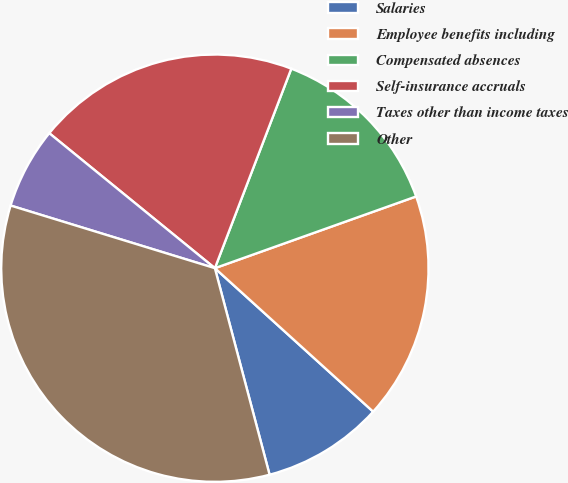Convert chart to OTSL. <chart><loc_0><loc_0><loc_500><loc_500><pie_chart><fcel>Salaries<fcel>Employee benefits including<fcel>Compensated absences<fcel>Self-insurance accruals<fcel>Taxes other than income taxes<fcel>Other<nl><fcel>9.16%<fcel>17.17%<fcel>13.73%<fcel>19.94%<fcel>6.15%<fcel>33.86%<nl></chart> 